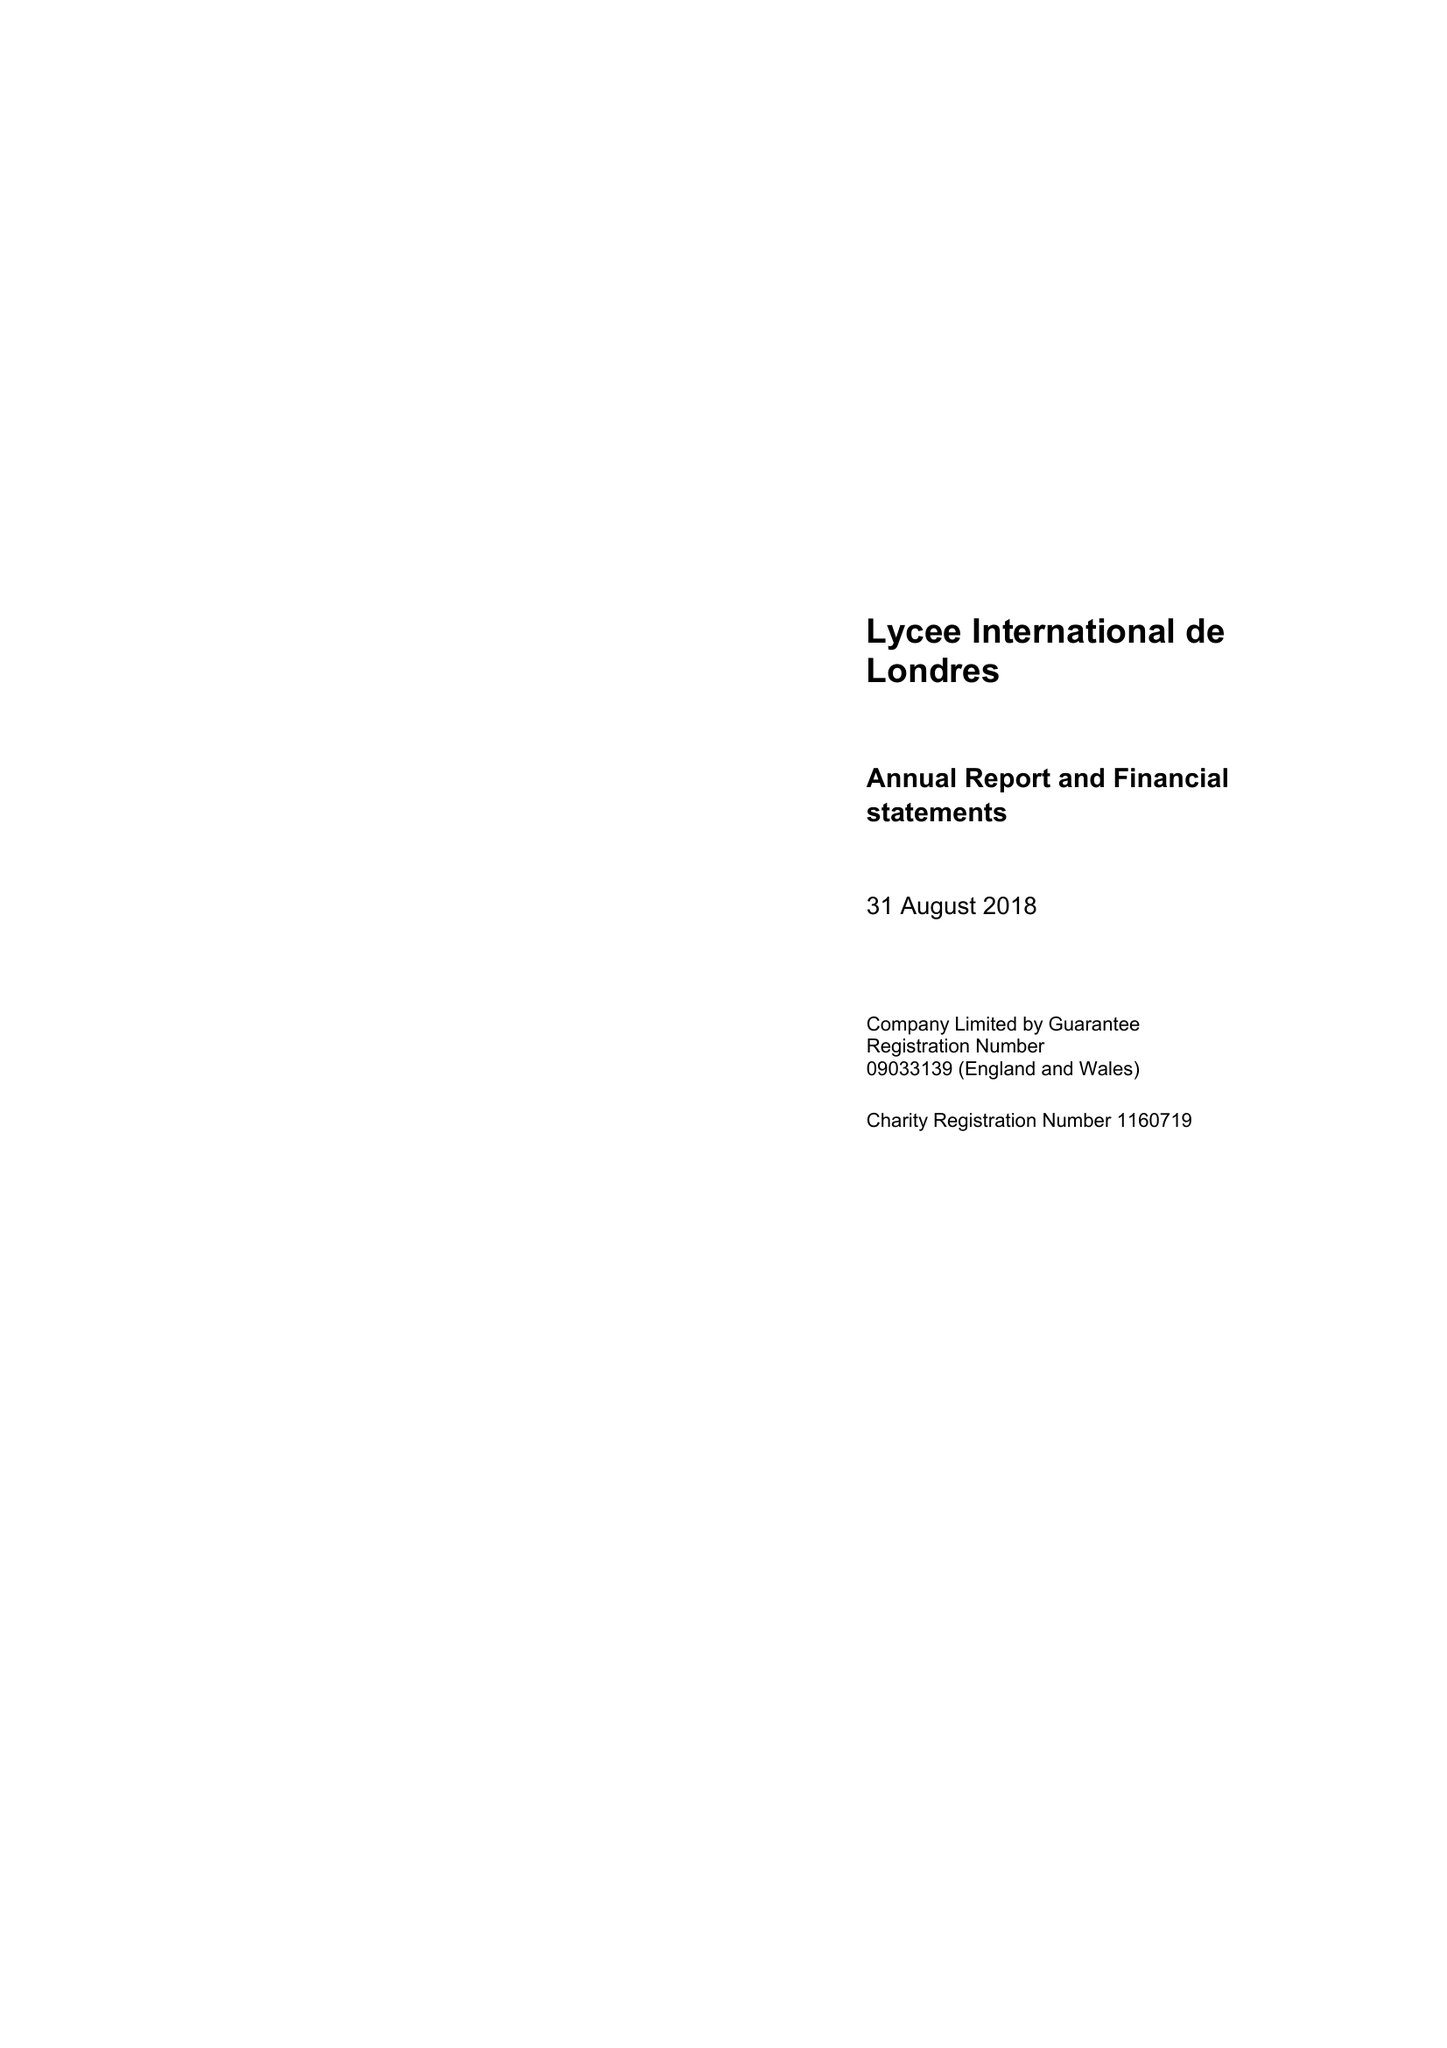What is the value for the income_annually_in_british_pounds?
Answer the question using a single word or phrase. 10836000.00 